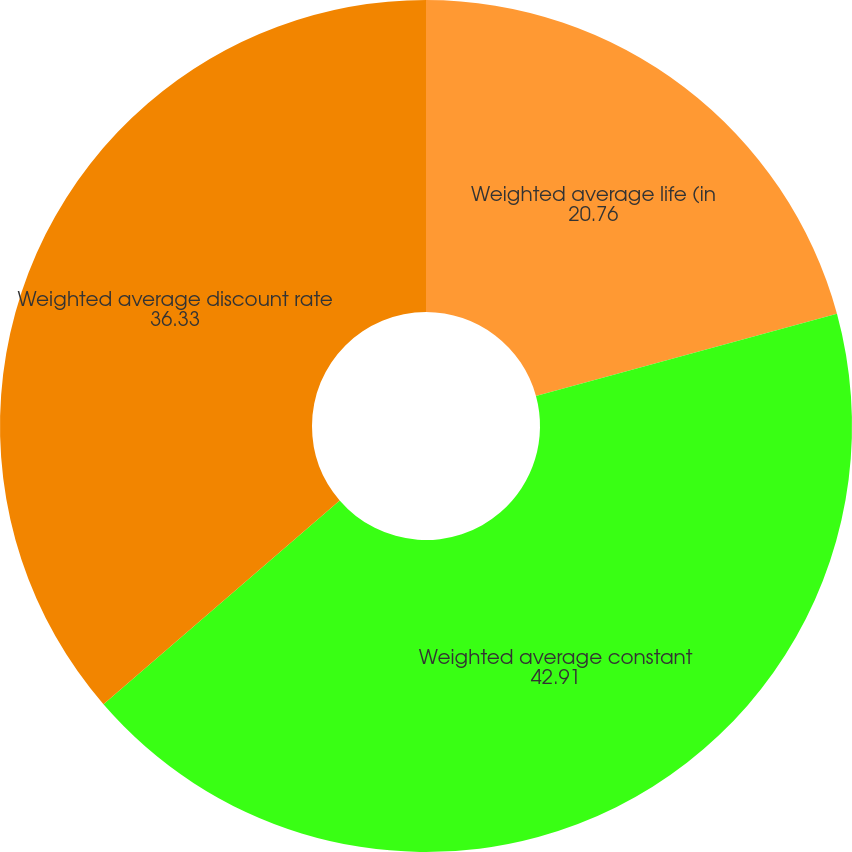Convert chart to OTSL. <chart><loc_0><loc_0><loc_500><loc_500><pie_chart><fcel>Weighted average life (in<fcel>Weighted average constant<fcel>Weighted average discount rate<nl><fcel>20.76%<fcel>42.91%<fcel>36.33%<nl></chart> 